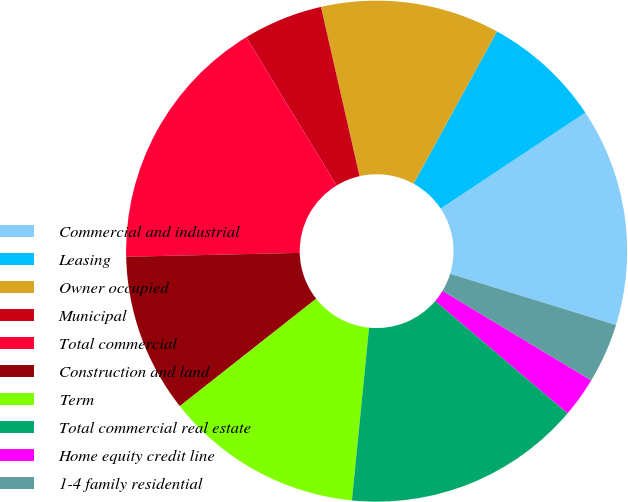Convert chart. <chart><loc_0><loc_0><loc_500><loc_500><pie_chart><fcel>Commercial and industrial<fcel>Leasing<fcel>Owner occupied<fcel>Municipal<fcel>Total commercial<fcel>Construction and land<fcel>Term<fcel>Total commercial real estate<fcel>Home equity credit line<fcel>1-4 family residential<nl><fcel>14.09%<fcel>7.7%<fcel>11.54%<fcel>5.14%<fcel>16.65%<fcel>10.26%<fcel>12.81%<fcel>15.37%<fcel>2.58%<fcel>3.86%<nl></chart> 